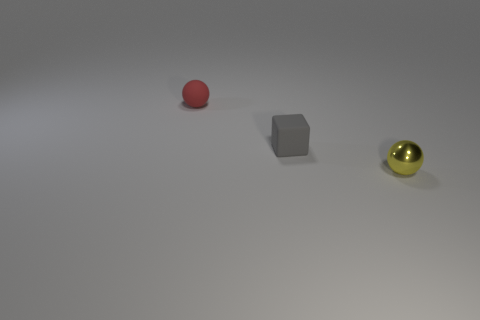Is there anything else that has the same material as the tiny yellow thing?
Give a very brief answer. No. How many tiny red balls are made of the same material as the yellow ball?
Your response must be concise. 0. Are there an equal number of tiny gray cubes that are behind the tiny matte sphere and gray rubber objects that are in front of the tiny yellow thing?
Your response must be concise. Yes. Is the shape of the red object the same as the tiny rubber thing in front of the small red sphere?
Offer a terse response. No. Is there anything else that has the same shape as the small yellow metallic thing?
Ensure brevity in your answer.  Yes. Is the tiny yellow thing made of the same material as the tiny sphere that is to the left of the small yellow object?
Make the answer very short. No. There is a tiny matte thing that is left of the matte object to the right of the tiny object that is behind the small gray rubber object; what color is it?
Provide a succinct answer. Red. Are there any other things that are the same size as the cube?
Make the answer very short. Yes. There is a matte ball; is it the same color as the small sphere to the right of the red ball?
Give a very brief answer. No. What is the color of the matte block?
Make the answer very short. Gray. 